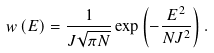<formula> <loc_0><loc_0><loc_500><loc_500>w \left ( E \right ) = \frac { 1 } { J \sqrt { \pi N } } \exp \left ( - \frac { E ^ { 2 } } { N J ^ { 2 } } \right ) .</formula> 